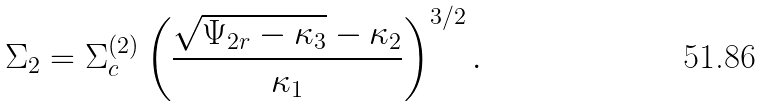Convert formula to latex. <formula><loc_0><loc_0><loc_500><loc_500>\Sigma _ { 2 } = \Sigma _ { c } ^ { ( 2 ) } \left ( \frac { \sqrt { \Psi _ { 2 r } - \kappa _ { 3 } } - \kappa _ { 2 } } { \kappa _ { 1 } } \right ) ^ { 3 / 2 } .</formula> 